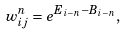<formula> <loc_0><loc_0><loc_500><loc_500>w _ { i j } ^ { n } = e ^ { E _ { i - n } - B _ { i - n } } ,</formula> 